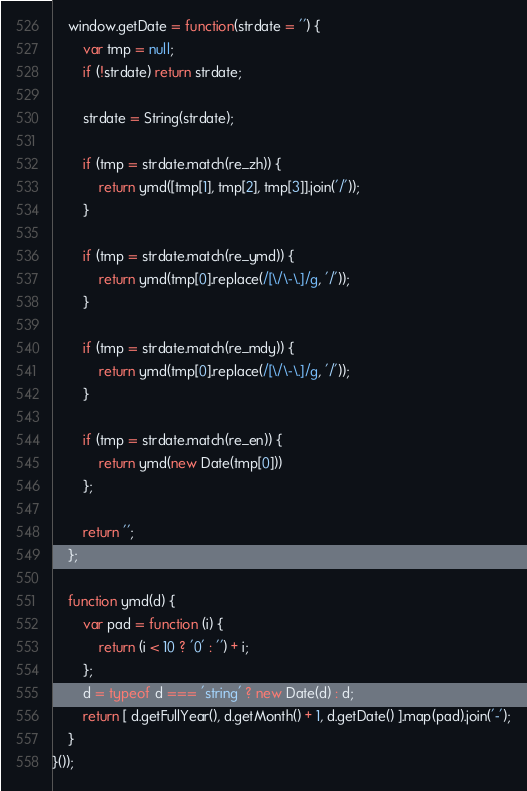<code> <loc_0><loc_0><loc_500><loc_500><_JavaScript_>    window.getDate = function(strdate = '') {
        var tmp = null;
        if (!strdate) return strdate;

        strdate = String(strdate);
            
        if (tmp = strdate.match(re_zh)) {
            return ymd([tmp[1], tmp[2], tmp[3]].join('/'));
        }

        if (tmp = strdate.match(re_ymd)) {
            return ymd(tmp[0].replace(/[\/\-\.]/g, '/'));
        }

        if (tmp = strdate.match(re_mdy)) {
            return ymd(tmp[0].replace(/[\/\-\.]/g, '/'));
        }

        if (tmp = strdate.match(re_en)) {
            return ymd(new Date(tmp[0]))
        };

        return '';
    };

    function ymd(d) {
        var pad = function (i) {
            return (i < 10 ? '0' : '') + i;
        };
        d = typeof d === 'string' ? new Date(d) : d;
        return [ d.getFullYear(), d.getMonth() + 1, d.getDate() ].map(pad).join('-');
    }
}());</code> 